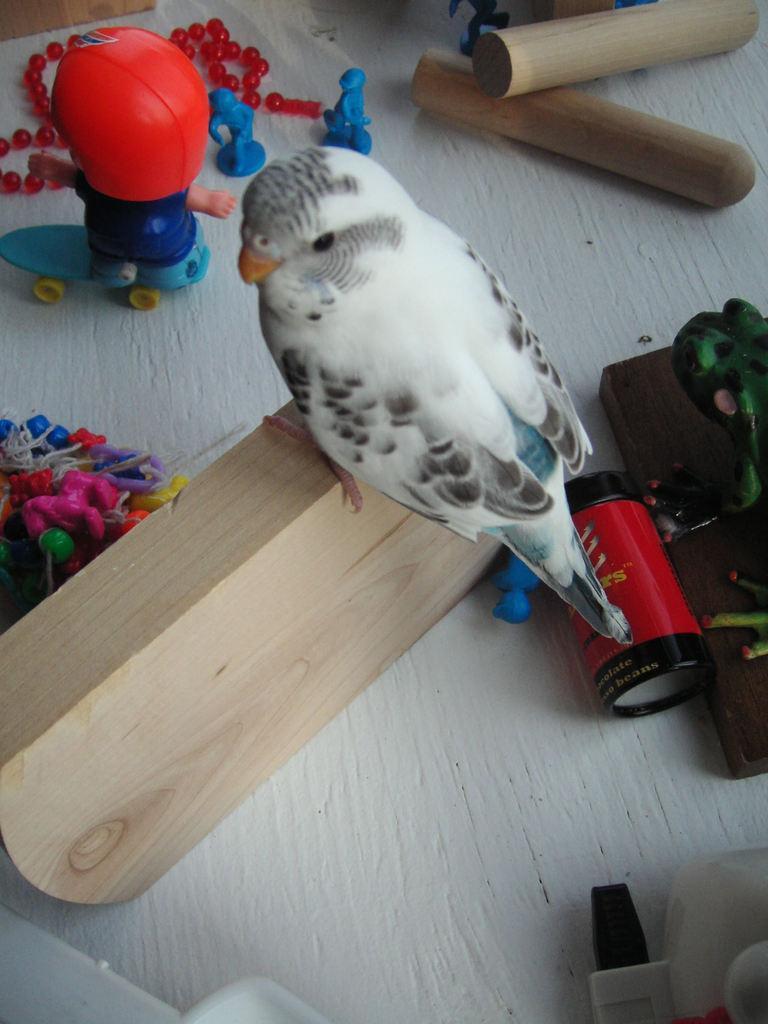Can you describe this image briefly? In this image, we can see a bird on the wooden piece. Here we can see few toys, some objects are placed on the white surface. 